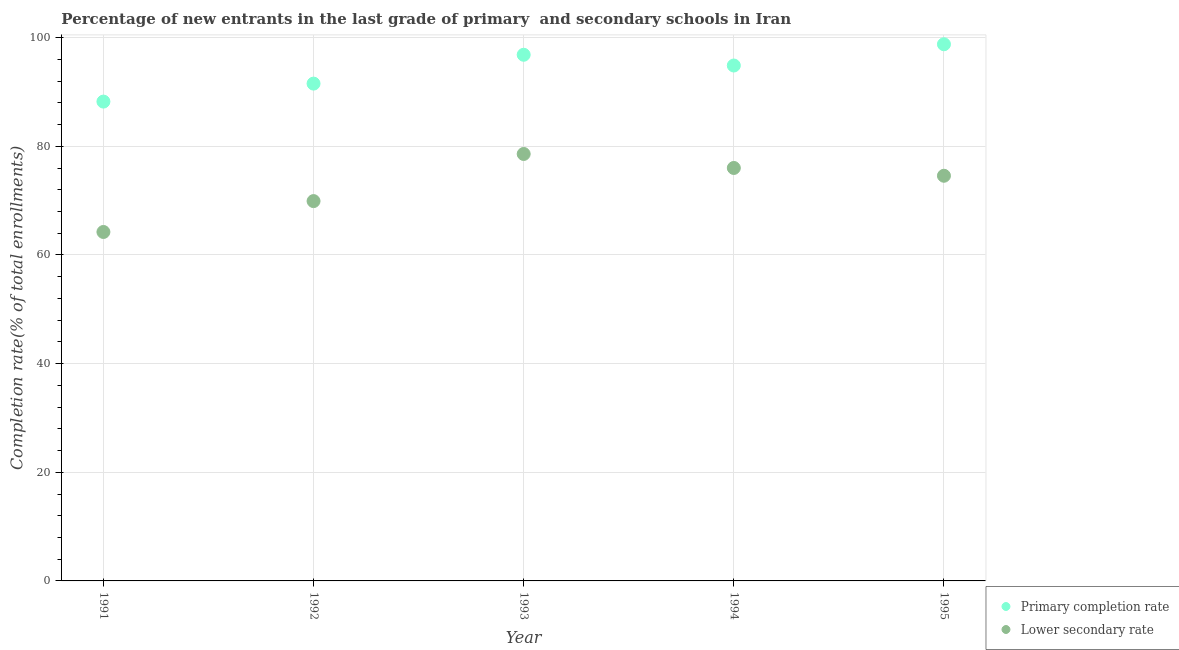Is the number of dotlines equal to the number of legend labels?
Keep it short and to the point. Yes. What is the completion rate in secondary schools in 1992?
Your answer should be very brief. 69.92. Across all years, what is the maximum completion rate in secondary schools?
Offer a terse response. 78.59. Across all years, what is the minimum completion rate in secondary schools?
Offer a very short reply. 64.23. In which year was the completion rate in secondary schools maximum?
Provide a succinct answer. 1993. What is the total completion rate in primary schools in the graph?
Ensure brevity in your answer.  470.29. What is the difference between the completion rate in secondary schools in 1991 and that in 1993?
Offer a terse response. -14.36. What is the difference between the completion rate in secondary schools in 1993 and the completion rate in primary schools in 1995?
Ensure brevity in your answer.  -20.19. What is the average completion rate in secondary schools per year?
Offer a very short reply. 72.67. In the year 1994, what is the difference between the completion rate in secondary schools and completion rate in primary schools?
Your answer should be compact. -18.86. In how many years, is the completion rate in secondary schools greater than 56 %?
Your answer should be very brief. 5. What is the ratio of the completion rate in primary schools in 1993 to that in 1994?
Offer a terse response. 1.02. Is the completion rate in primary schools in 1991 less than that in 1992?
Your answer should be compact. Yes. Is the difference between the completion rate in primary schools in 1992 and 1995 greater than the difference between the completion rate in secondary schools in 1992 and 1995?
Your answer should be compact. No. What is the difference between the highest and the second highest completion rate in secondary schools?
Offer a terse response. 2.58. What is the difference between the highest and the lowest completion rate in primary schools?
Offer a very short reply. 10.55. In how many years, is the completion rate in secondary schools greater than the average completion rate in secondary schools taken over all years?
Give a very brief answer. 3. Is the completion rate in primary schools strictly greater than the completion rate in secondary schools over the years?
Provide a succinct answer. Yes. Is the completion rate in primary schools strictly less than the completion rate in secondary schools over the years?
Provide a short and direct response. No. Where does the legend appear in the graph?
Provide a short and direct response. Bottom right. What is the title of the graph?
Your answer should be compact. Percentage of new entrants in the last grade of primary  and secondary schools in Iran. Does "Secondary education" appear as one of the legend labels in the graph?
Keep it short and to the point. No. What is the label or title of the X-axis?
Keep it short and to the point. Year. What is the label or title of the Y-axis?
Offer a very short reply. Completion rate(% of total enrollments). What is the Completion rate(% of total enrollments) in Primary completion rate in 1991?
Give a very brief answer. 88.23. What is the Completion rate(% of total enrollments) in Lower secondary rate in 1991?
Make the answer very short. 64.23. What is the Completion rate(% of total enrollments) in Primary completion rate in 1992?
Your answer should be compact. 91.54. What is the Completion rate(% of total enrollments) of Lower secondary rate in 1992?
Give a very brief answer. 69.92. What is the Completion rate(% of total enrollments) of Primary completion rate in 1993?
Provide a succinct answer. 96.85. What is the Completion rate(% of total enrollments) of Lower secondary rate in 1993?
Offer a terse response. 78.59. What is the Completion rate(% of total enrollments) of Primary completion rate in 1994?
Give a very brief answer. 94.87. What is the Completion rate(% of total enrollments) in Lower secondary rate in 1994?
Provide a short and direct response. 76.02. What is the Completion rate(% of total enrollments) in Primary completion rate in 1995?
Your answer should be compact. 98.79. What is the Completion rate(% of total enrollments) of Lower secondary rate in 1995?
Provide a succinct answer. 74.58. Across all years, what is the maximum Completion rate(% of total enrollments) in Primary completion rate?
Offer a very short reply. 98.79. Across all years, what is the maximum Completion rate(% of total enrollments) of Lower secondary rate?
Provide a short and direct response. 78.59. Across all years, what is the minimum Completion rate(% of total enrollments) in Primary completion rate?
Make the answer very short. 88.23. Across all years, what is the minimum Completion rate(% of total enrollments) of Lower secondary rate?
Your response must be concise. 64.23. What is the total Completion rate(% of total enrollments) of Primary completion rate in the graph?
Your answer should be compact. 470.29. What is the total Completion rate(% of total enrollments) in Lower secondary rate in the graph?
Ensure brevity in your answer.  363.34. What is the difference between the Completion rate(% of total enrollments) in Primary completion rate in 1991 and that in 1992?
Provide a succinct answer. -3.31. What is the difference between the Completion rate(% of total enrollments) of Lower secondary rate in 1991 and that in 1992?
Offer a terse response. -5.68. What is the difference between the Completion rate(% of total enrollments) in Primary completion rate in 1991 and that in 1993?
Ensure brevity in your answer.  -8.62. What is the difference between the Completion rate(% of total enrollments) in Lower secondary rate in 1991 and that in 1993?
Your response must be concise. -14.36. What is the difference between the Completion rate(% of total enrollments) in Primary completion rate in 1991 and that in 1994?
Offer a terse response. -6.64. What is the difference between the Completion rate(% of total enrollments) of Lower secondary rate in 1991 and that in 1994?
Keep it short and to the point. -11.78. What is the difference between the Completion rate(% of total enrollments) in Primary completion rate in 1991 and that in 1995?
Make the answer very short. -10.55. What is the difference between the Completion rate(% of total enrollments) in Lower secondary rate in 1991 and that in 1995?
Your answer should be compact. -10.35. What is the difference between the Completion rate(% of total enrollments) in Primary completion rate in 1992 and that in 1993?
Offer a very short reply. -5.31. What is the difference between the Completion rate(% of total enrollments) of Lower secondary rate in 1992 and that in 1993?
Provide a short and direct response. -8.68. What is the difference between the Completion rate(% of total enrollments) of Primary completion rate in 1992 and that in 1994?
Offer a terse response. -3.33. What is the difference between the Completion rate(% of total enrollments) of Lower secondary rate in 1992 and that in 1994?
Provide a short and direct response. -6.1. What is the difference between the Completion rate(% of total enrollments) of Primary completion rate in 1992 and that in 1995?
Keep it short and to the point. -7.24. What is the difference between the Completion rate(% of total enrollments) in Lower secondary rate in 1992 and that in 1995?
Your answer should be compact. -4.66. What is the difference between the Completion rate(% of total enrollments) in Primary completion rate in 1993 and that in 1994?
Offer a terse response. 1.98. What is the difference between the Completion rate(% of total enrollments) of Lower secondary rate in 1993 and that in 1994?
Your answer should be compact. 2.58. What is the difference between the Completion rate(% of total enrollments) of Primary completion rate in 1993 and that in 1995?
Give a very brief answer. -1.93. What is the difference between the Completion rate(% of total enrollments) of Lower secondary rate in 1993 and that in 1995?
Offer a terse response. 4.01. What is the difference between the Completion rate(% of total enrollments) of Primary completion rate in 1994 and that in 1995?
Keep it short and to the point. -3.91. What is the difference between the Completion rate(% of total enrollments) of Lower secondary rate in 1994 and that in 1995?
Offer a very short reply. 1.43. What is the difference between the Completion rate(% of total enrollments) of Primary completion rate in 1991 and the Completion rate(% of total enrollments) of Lower secondary rate in 1992?
Give a very brief answer. 18.32. What is the difference between the Completion rate(% of total enrollments) in Primary completion rate in 1991 and the Completion rate(% of total enrollments) in Lower secondary rate in 1993?
Make the answer very short. 9.64. What is the difference between the Completion rate(% of total enrollments) of Primary completion rate in 1991 and the Completion rate(% of total enrollments) of Lower secondary rate in 1994?
Keep it short and to the point. 12.22. What is the difference between the Completion rate(% of total enrollments) of Primary completion rate in 1991 and the Completion rate(% of total enrollments) of Lower secondary rate in 1995?
Your answer should be very brief. 13.65. What is the difference between the Completion rate(% of total enrollments) in Primary completion rate in 1992 and the Completion rate(% of total enrollments) in Lower secondary rate in 1993?
Offer a terse response. 12.95. What is the difference between the Completion rate(% of total enrollments) in Primary completion rate in 1992 and the Completion rate(% of total enrollments) in Lower secondary rate in 1994?
Keep it short and to the point. 15.53. What is the difference between the Completion rate(% of total enrollments) in Primary completion rate in 1992 and the Completion rate(% of total enrollments) in Lower secondary rate in 1995?
Offer a very short reply. 16.96. What is the difference between the Completion rate(% of total enrollments) in Primary completion rate in 1993 and the Completion rate(% of total enrollments) in Lower secondary rate in 1994?
Your answer should be compact. 20.84. What is the difference between the Completion rate(% of total enrollments) in Primary completion rate in 1993 and the Completion rate(% of total enrollments) in Lower secondary rate in 1995?
Your answer should be compact. 22.27. What is the difference between the Completion rate(% of total enrollments) in Primary completion rate in 1994 and the Completion rate(% of total enrollments) in Lower secondary rate in 1995?
Make the answer very short. 20.29. What is the average Completion rate(% of total enrollments) of Primary completion rate per year?
Your response must be concise. 94.06. What is the average Completion rate(% of total enrollments) in Lower secondary rate per year?
Make the answer very short. 72.67. In the year 1991, what is the difference between the Completion rate(% of total enrollments) in Primary completion rate and Completion rate(% of total enrollments) in Lower secondary rate?
Give a very brief answer. 24. In the year 1992, what is the difference between the Completion rate(% of total enrollments) in Primary completion rate and Completion rate(% of total enrollments) in Lower secondary rate?
Offer a very short reply. 21.63. In the year 1993, what is the difference between the Completion rate(% of total enrollments) in Primary completion rate and Completion rate(% of total enrollments) in Lower secondary rate?
Your answer should be very brief. 18.26. In the year 1994, what is the difference between the Completion rate(% of total enrollments) of Primary completion rate and Completion rate(% of total enrollments) of Lower secondary rate?
Offer a terse response. 18.86. In the year 1995, what is the difference between the Completion rate(% of total enrollments) in Primary completion rate and Completion rate(% of total enrollments) in Lower secondary rate?
Your answer should be compact. 24.21. What is the ratio of the Completion rate(% of total enrollments) of Primary completion rate in 1991 to that in 1992?
Keep it short and to the point. 0.96. What is the ratio of the Completion rate(% of total enrollments) of Lower secondary rate in 1991 to that in 1992?
Your answer should be very brief. 0.92. What is the ratio of the Completion rate(% of total enrollments) in Primary completion rate in 1991 to that in 1993?
Provide a succinct answer. 0.91. What is the ratio of the Completion rate(% of total enrollments) of Lower secondary rate in 1991 to that in 1993?
Offer a terse response. 0.82. What is the ratio of the Completion rate(% of total enrollments) in Lower secondary rate in 1991 to that in 1994?
Offer a terse response. 0.84. What is the ratio of the Completion rate(% of total enrollments) of Primary completion rate in 1991 to that in 1995?
Offer a very short reply. 0.89. What is the ratio of the Completion rate(% of total enrollments) in Lower secondary rate in 1991 to that in 1995?
Offer a very short reply. 0.86. What is the ratio of the Completion rate(% of total enrollments) of Primary completion rate in 1992 to that in 1993?
Offer a very short reply. 0.95. What is the ratio of the Completion rate(% of total enrollments) in Lower secondary rate in 1992 to that in 1993?
Offer a terse response. 0.89. What is the ratio of the Completion rate(% of total enrollments) in Primary completion rate in 1992 to that in 1994?
Provide a succinct answer. 0.96. What is the ratio of the Completion rate(% of total enrollments) in Lower secondary rate in 1992 to that in 1994?
Your answer should be compact. 0.92. What is the ratio of the Completion rate(% of total enrollments) of Primary completion rate in 1992 to that in 1995?
Give a very brief answer. 0.93. What is the ratio of the Completion rate(% of total enrollments) in Lower secondary rate in 1992 to that in 1995?
Offer a terse response. 0.94. What is the ratio of the Completion rate(% of total enrollments) of Primary completion rate in 1993 to that in 1994?
Your answer should be compact. 1.02. What is the ratio of the Completion rate(% of total enrollments) of Lower secondary rate in 1993 to that in 1994?
Provide a succinct answer. 1.03. What is the ratio of the Completion rate(% of total enrollments) in Primary completion rate in 1993 to that in 1995?
Your answer should be compact. 0.98. What is the ratio of the Completion rate(% of total enrollments) in Lower secondary rate in 1993 to that in 1995?
Offer a very short reply. 1.05. What is the ratio of the Completion rate(% of total enrollments) of Primary completion rate in 1994 to that in 1995?
Give a very brief answer. 0.96. What is the ratio of the Completion rate(% of total enrollments) of Lower secondary rate in 1994 to that in 1995?
Provide a short and direct response. 1.02. What is the difference between the highest and the second highest Completion rate(% of total enrollments) in Primary completion rate?
Provide a short and direct response. 1.93. What is the difference between the highest and the second highest Completion rate(% of total enrollments) of Lower secondary rate?
Make the answer very short. 2.58. What is the difference between the highest and the lowest Completion rate(% of total enrollments) of Primary completion rate?
Give a very brief answer. 10.55. What is the difference between the highest and the lowest Completion rate(% of total enrollments) in Lower secondary rate?
Offer a very short reply. 14.36. 